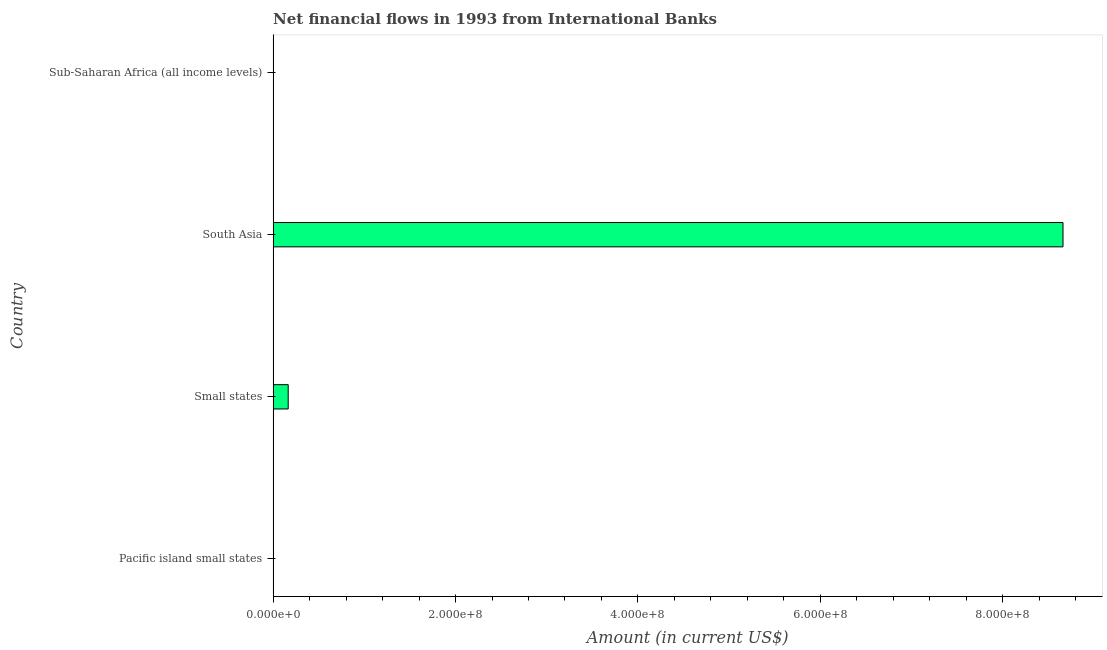What is the title of the graph?
Offer a very short reply. Net financial flows in 1993 from International Banks. What is the label or title of the X-axis?
Give a very brief answer. Amount (in current US$). What is the label or title of the Y-axis?
Provide a succinct answer. Country. What is the net financial flows from ibrd in South Asia?
Keep it short and to the point. 8.66e+08. Across all countries, what is the maximum net financial flows from ibrd?
Offer a very short reply. 8.66e+08. Across all countries, what is the minimum net financial flows from ibrd?
Your response must be concise. 0. In which country was the net financial flows from ibrd maximum?
Make the answer very short. South Asia. What is the sum of the net financial flows from ibrd?
Provide a short and direct response. 8.83e+08. What is the difference between the net financial flows from ibrd in Small states and South Asia?
Provide a short and direct response. -8.50e+08. What is the average net financial flows from ibrd per country?
Provide a short and direct response. 2.21e+08. What is the median net financial flows from ibrd?
Your answer should be very brief. 8.27e+06. In how many countries, is the net financial flows from ibrd greater than 800000000 US$?
Your answer should be very brief. 1. Is the net financial flows from ibrd in Small states less than that in South Asia?
Your response must be concise. Yes. What is the difference between the highest and the lowest net financial flows from ibrd?
Offer a very short reply. 8.66e+08. In how many countries, is the net financial flows from ibrd greater than the average net financial flows from ibrd taken over all countries?
Provide a short and direct response. 1. Are all the bars in the graph horizontal?
Your response must be concise. Yes. What is the difference between two consecutive major ticks on the X-axis?
Give a very brief answer. 2.00e+08. What is the Amount (in current US$) in Pacific island small states?
Provide a short and direct response. 0. What is the Amount (in current US$) of Small states?
Keep it short and to the point. 1.65e+07. What is the Amount (in current US$) of South Asia?
Provide a short and direct response. 8.66e+08. What is the Amount (in current US$) of Sub-Saharan Africa (all income levels)?
Your response must be concise. 0. What is the difference between the Amount (in current US$) in Small states and South Asia?
Provide a short and direct response. -8.50e+08. What is the ratio of the Amount (in current US$) in Small states to that in South Asia?
Your response must be concise. 0.02. 